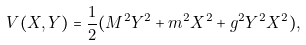Convert formula to latex. <formula><loc_0><loc_0><loc_500><loc_500>V ( X , Y ) = \frac { 1 } { 2 } ( M ^ { 2 } Y ^ { 2 } + m ^ { 2 } X ^ { 2 } + g ^ { 2 } Y ^ { 2 } X ^ { 2 } ) ,</formula> 